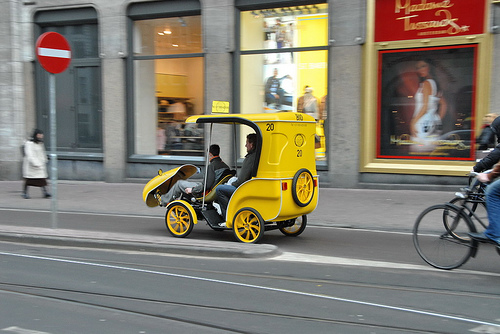Please transcribe the text information in this image. 20 Tusards 